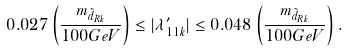<formula> <loc_0><loc_0><loc_500><loc_500>0 . 0 2 7 \left ( \frac { m _ { \tilde { d } _ { R k } } } { 1 0 0 G e V } \right ) \leq | \lambda ^ { \prime } _ { 1 1 k } | \leq 0 . 0 4 8 \left ( \frac { m _ { \tilde { d } _ { R k } } } { 1 0 0 G e V } \right ) .</formula> 